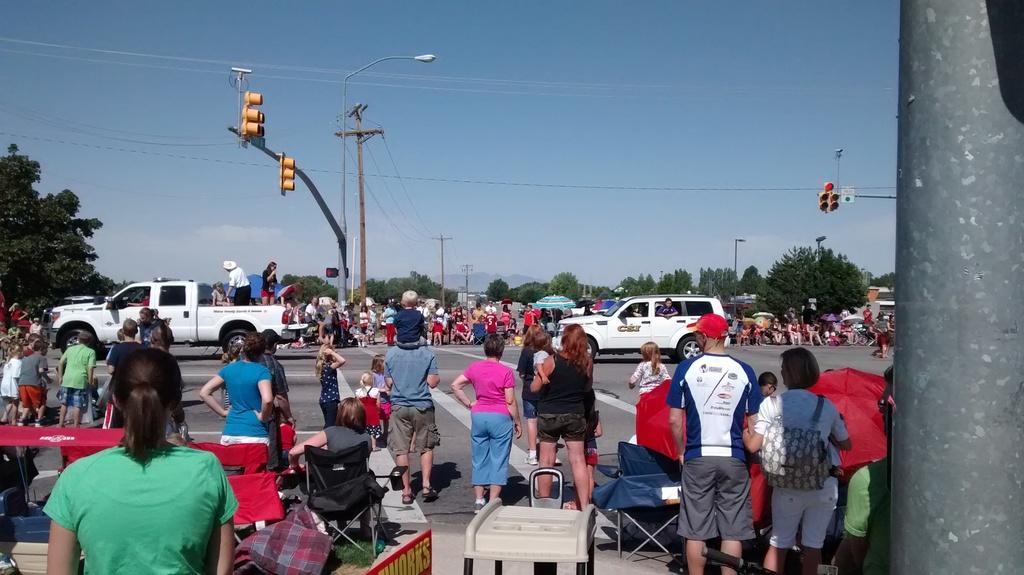Can you describe this image briefly? In this image we can see many people. On the right side is a pillar. And few people are sitting on chairs. And there are traffic lights with pole. Also there are electric poles and light pole. In the background there are trees. Also there are vehicles on the road. There are few people on the vehicles. On the left side there is a table. In the background there is sky. 